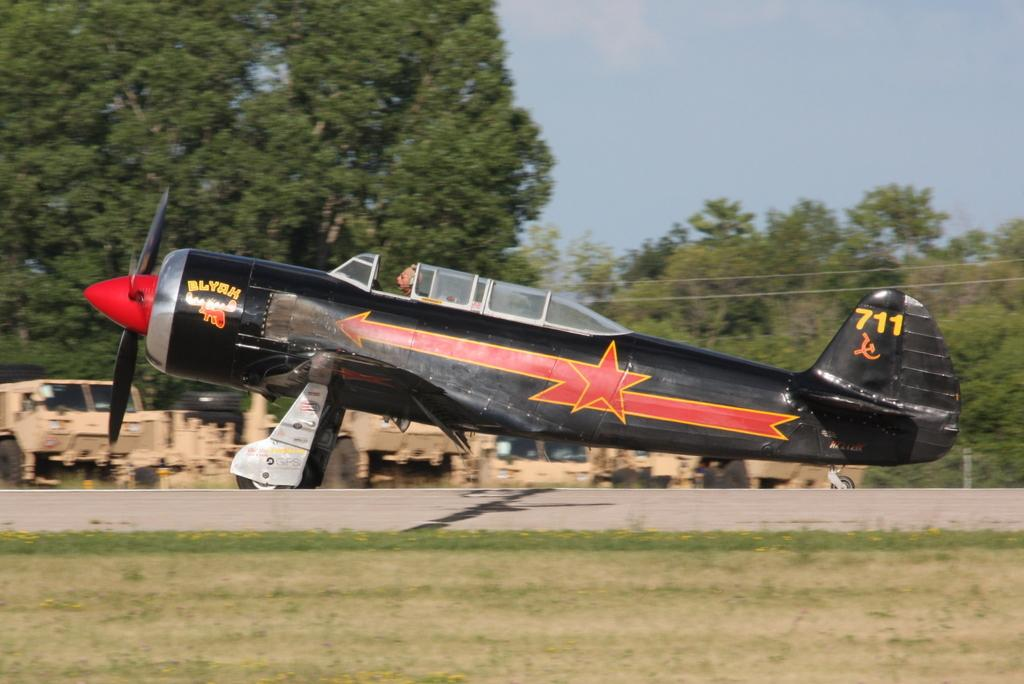What is the main subject in the center of the image? There is an aircraft in the center of the image. What can be seen in the background of the image? There are trees and vehicles visible on the road in the background. What is visible at the top of the image? The sky is visible at the top of the image. How long does it take for the cup to sort itself out in the image? There is no cup present in the image, so it cannot be sorted or timed. 